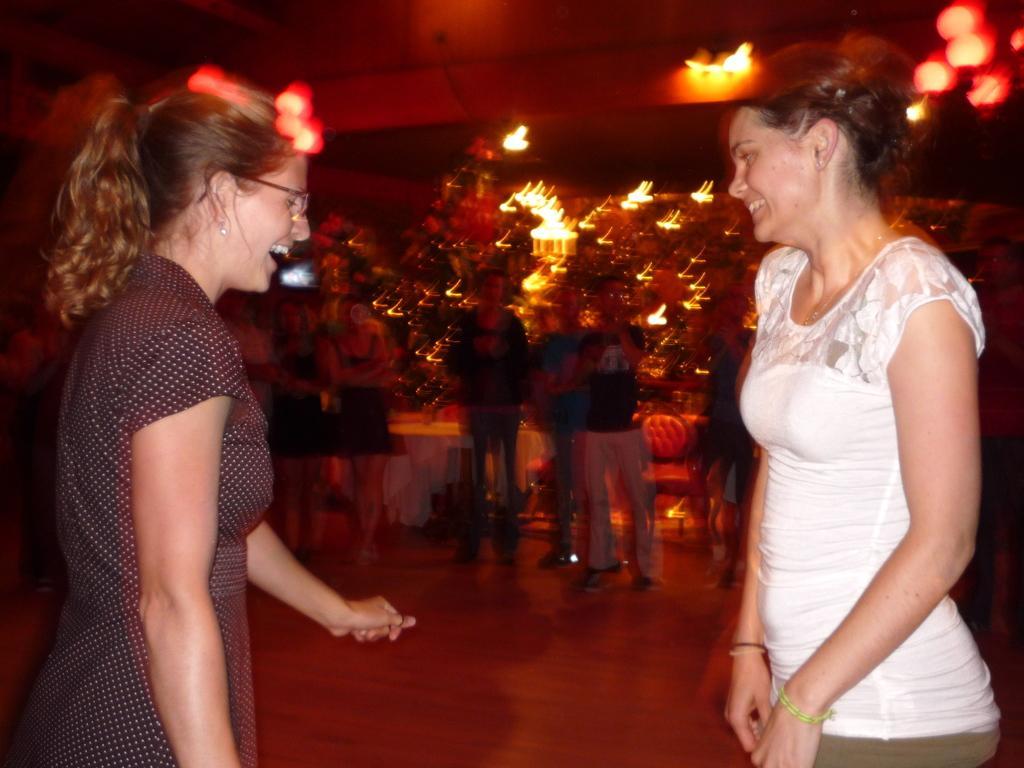How would you summarize this image in a sentence or two? In this image in the foreground there are two women who are standing and they are smiling, and in the background there are some people who are standing and there are some trees and lights. And also there are some tables and chairs, at the top there is ceiling and some lights and at the bottom there is a floor. 